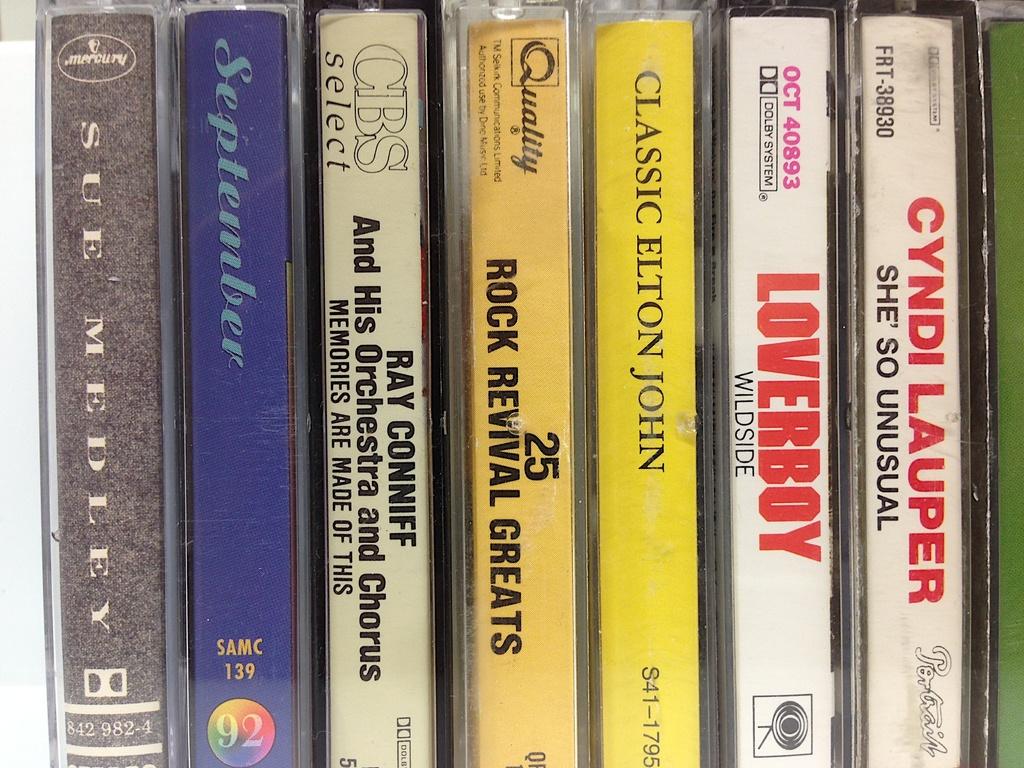What are the artist's names on the tape cassettes?
Provide a short and direct response. Cyndi lauper, loverboy, elton john, ray conniff, september, sue medley. Which one is loverboy?
Your answer should be very brief. Wildside. 